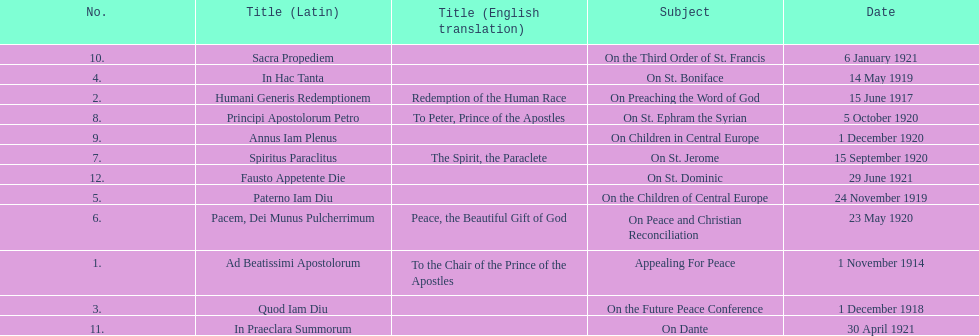Other than january how many encyclicals were in 1921? 2. 